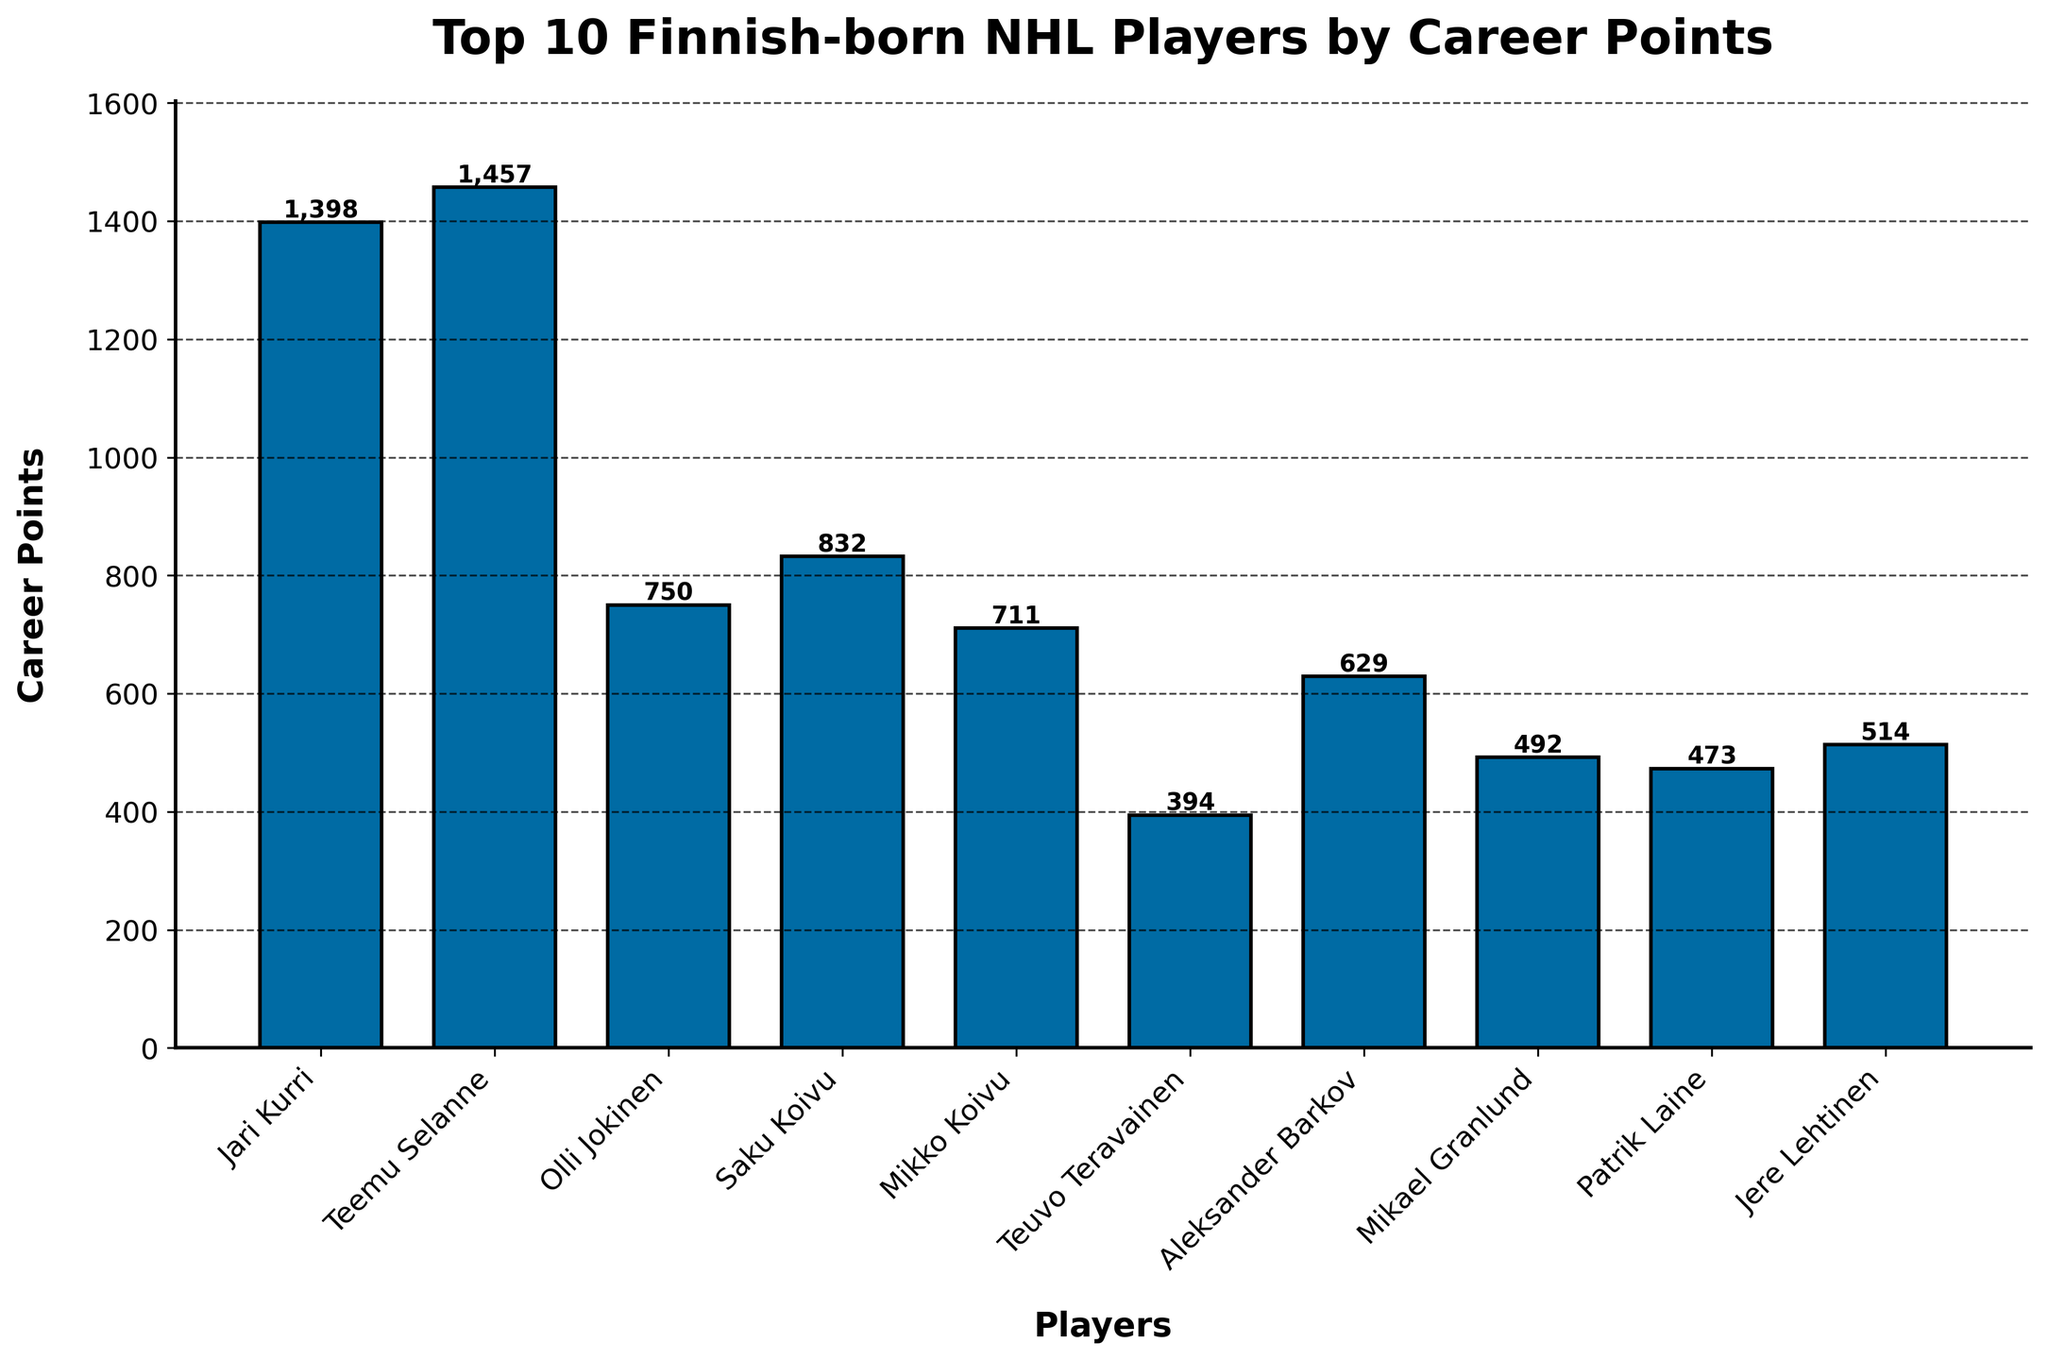Which player has the highest career points? Teemu Selanne has the highest bar.
Answer: Teemu Selanne How many more career points does Teemu Selanne have compared to Jari Kurri? Teemu Selanne has 1457 points and Jari Kurri has 1398. Subtract Jari Kurri's points from Teemu Selanne's: 1457 - 1398 = 59.
Answer: 59 Who has the lowest career points among the top 10 Finnish-born NHL players? Observing the shortest bar, Teuvo Teravainen has the lowest points at 394.
Answer: Teuvo Teravainen What is the sum of career points for Saku Koivu and Mikko Koivu? Saku Koivu has 832 points and Mikko Koivu has 711. Adding their points: 832 + 711 = 1543.
Answer: 1543 Which player has fewer career points, Patrik Laine or Jere Lehtinen? Patrik Laine has 473 points, and Jere Lehtinen has 514 points. Patrik Laine has fewer career points.
Answer: Patrik Laine Among the players listed, who ranks third in terms of career points? The third highest bar corresponds to Olli Jokinen with 750 points.
Answer: Olli Jokinen What is the difference in career points between the player with the highest points and the player with the lowest points? Teemu Selanne has the highest points at 1457, and Teuvo Teravainen has the lowest at 394. Subtract the lowest from the highest: 1457 - 394 = 1063.
Answer: 1063 How many players have career points greater than 500? The players with bars higher than 500 on the y-axis are Jari Kurri, Teemu Selanne, Olli Jokinen, Saku Koivu, Mikko Koivu, and Jere Lehtinen, totaling six players.
Answer: 6 What is the average career points of the top 5 players? The top 5 players are Teemu Selanne, Jari Kurri, Saku Koivu, Olli Jokinen, and Mikko Koivu. Adding their points: 1457 + 1398 + 832 + 750 + 711 = 5148. Dividing by 5: 5148 / 5 = 1029.6.
Answer: 1029.6 